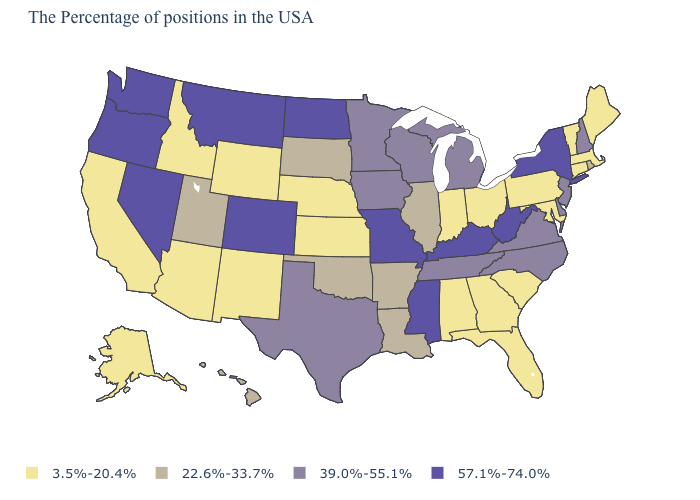Does Washington have the same value as Wisconsin?
Answer briefly. No. What is the lowest value in states that border Connecticut?
Be succinct. 3.5%-20.4%. What is the value of Virginia?
Concise answer only. 39.0%-55.1%. What is the value of North Carolina?
Quick response, please. 39.0%-55.1%. Among the states that border Michigan , does Indiana have the lowest value?
Write a very short answer. Yes. Name the states that have a value in the range 22.6%-33.7%?
Give a very brief answer. Rhode Island, Illinois, Louisiana, Arkansas, Oklahoma, South Dakota, Utah, Hawaii. Does Wisconsin have a lower value than Montana?
Be succinct. Yes. Which states have the lowest value in the USA?
Be succinct. Maine, Massachusetts, Vermont, Connecticut, Maryland, Pennsylvania, South Carolina, Ohio, Florida, Georgia, Indiana, Alabama, Kansas, Nebraska, Wyoming, New Mexico, Arizona, Idaho, California, Alaska. Does Louisiana have a higher value than Utah?
Be succinct. No. Name the states that have a value in the range 39.0%-55.1%?
Answer briefly. New Hampshire, New Jersey, Delaware, Virginia, North Carolina, Michigan, Tennessee, Wisconsin, Minnesota, Iowa, Texas. What is the value of Kentucky?
Write a very short answer. 57.1%-74.0%. What is the lowest value in the USA?
Short answer required. 3.5%-20.4%. Does the map have missing data?
Be succinct. No. Name the states that have a value in the range 3.5%-20.4%?
Write a very short answer. Maine, Massachusetts, Vermont, Connecticut, Maryland, Pennsylvania, South Carolina, Ohio, Florida, Georgia, Indiana, Alabama, Kansas, Nebraska, Wyoming, New Mexico, Arizona, Idaho, California, Alaska. Which states have the lowest value in the USA?
Short answer required. Maine, Massachusetts, Vermont, Connecticut, Maryland, Pennsylvania, South Carolina, Ohio, Florida, Georgia, Indiana, Alabama, Kansas, Nebraska, Wyoming, New Mexico, Arizona, Idaho, California, Alaska. 